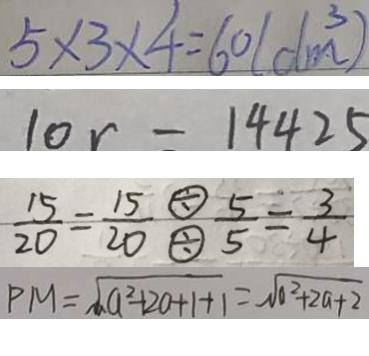Convert formula to latex. <formula><loc_0><loc_0><loc_500><loc_500>5 \times 3 \times 4 = 6 0 ( d m ^ { 3 } ) 
 1 0 r = 1 4 4 2 5 
 \frac { 1 5 } { 2 0 } = \frac { 1 5 } { 2 0 } ^ { \textcircled { \div } } _ { \textcircled { \div } } \frac { 5 } { 5 } = \frac { 3 } { 4 } 
 P M = \sqrt { a ^ { 2 } + 2 0 + 1 + 1 } = \sqrt { 0 ^ { 2 } + 2 a + 2 }</formula> 